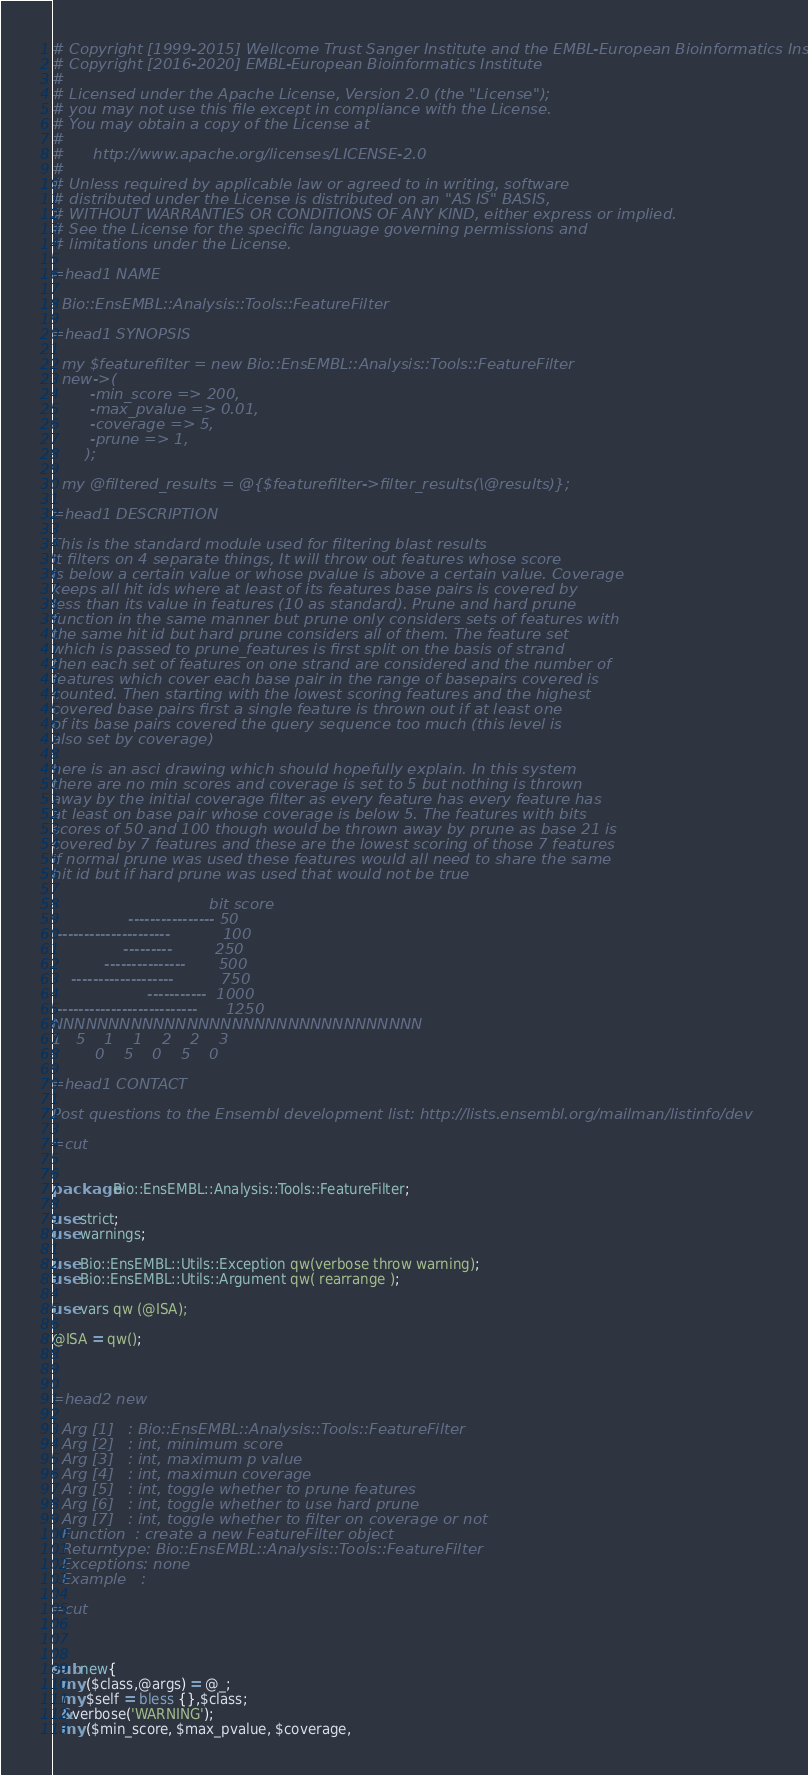<code> <loc_0><loc_0><loc_500><loc_500><_Perl_># Copyright [1999-2015] Wellcome Trust Sanger Institute and the EMBL-European Bioinformatics Institute
# Copyright [2016-2020] EMBL-European Bioinformatics Institute
# 
# Licensed under the Apache License, Version 2.0 (the "License");
# you may not use this file except in compliance with the License.
# You may obtain a copy of the License at
# 
#      http://www.apache.org/licenses/LICENSE-2.0
# 
# Unless required by applicable law or agreed to in writing, software
# distributed under the License is distributed on an "AS IS" BASIS,
# WITHOUT WARRANTIES OR CONDITIONS OF ANY KIND, either express or implied.
# See the License for the specific language governing permissions and
# limitations under the License.

=head1 NAME

  Bio::EnsEMBL::Analysis::Tools::FeatureFilter

=head1 SYNOPSIS

  my $featurefilter = new Bio::EnsEMBL::Analysis::Tools::FeatureFilter
  new->(
        -min_score => 200,
        -max_pvalue => 0.01,
        -coverage => 5,
        -prune => 1,
       );

  my @filtered_results = @{$featurefilter->filter_results(\@results)};

=head1 DESCRIPTION

This is the standard module used for filtering blast results
It filters on 4 separate things, It will throw out features whose score
is below a certain value or whose pvalue is above a certain value. Coverage
keeps all hit ids where at least of its features base pairs is covered by 
less than its value in features (10 as standard). Prune and hard prune 
function in the same manner but prune only considers sets of features with
the same hit id but hard prune considers all of them. The feature set
which is passed to prune_features is first split on the basis of strand
then each set of features on one strand are considered and the number of
features which cover each base pair in the range of basepairs covered is
counted. Then starting with the lowest scoring features and the highest
covered base pairs first a single feature is thrown out if at least one
of its base pairs covered the query sequence too much (this level is
also set by coverage)

here is an asci drawing which should hopefully explain. In this system
there are no min scores and coverage is set to 5 but nothing is thrown
away by the initial coverage filter as every feature has every feature has
at least on base pair whose coverage is below 5. The features with bits 
scores of 50 and 100 though would be thrown away by prune as base 21 is
covered by 7 features and these are the lowest scoring of those 7 features
if normal prune was used these features would all need to share the same 
hit id but if hard prune was used that would not be true

                                 bit score
                ---------------- 50
 ---------------------           100
               ---------         250
           ---------------       500
    -------------------          750
                    -----------  1000
 --------------------------      1250
NNNNNNNNNNNNNNNNNNNNNNNNNNNNNNNNN
1   5    1    1    2    2    3
         0    5    0    5    0

=head1 CONTACT

Post questions to the Ensembl development list: http://lists.ensembl.org/mailman/listinfo/dev

=cut


package Bio::EnsEMBL::Analysis::Tools::FeatureFilter;

use strict;
use warnings;

use Bio::EnsEMBL::Utils::Exception qw(verbose throw warning);
use Bio::EnsEMBL::Utils::Argument qw( rearrange );

use vars qw (@ISA);

@ISA = qw();



=head2 new

  Arg [1]   : Bio::EnsEMBL::Analysis::Tools::FeatureFilter
  Arg [2]   : int, minimum score
  Arg [3]   : int, maximum p value
  Arg [4]   : int, maximun coverage
  Arg [5]   : int, toggle whether to prune features
  Arg [6]   : int, toggle whether to use hard prune
  Arg [7]   : int, toggle whether to filter on coverage or not
  Function  : create a new FeatureFilter object
  Returntype: Bio::EnsEMBL::Analysis::Tools::FeatureFilter
  Exceptions: none
  Example   : 

=cut



sub new{
  my ($class,@args) = @_;
  my $self = bless {},$class;
  &verbose('WARNING');
  my ($min_score, $max_pvalue, $coverage,</code> 